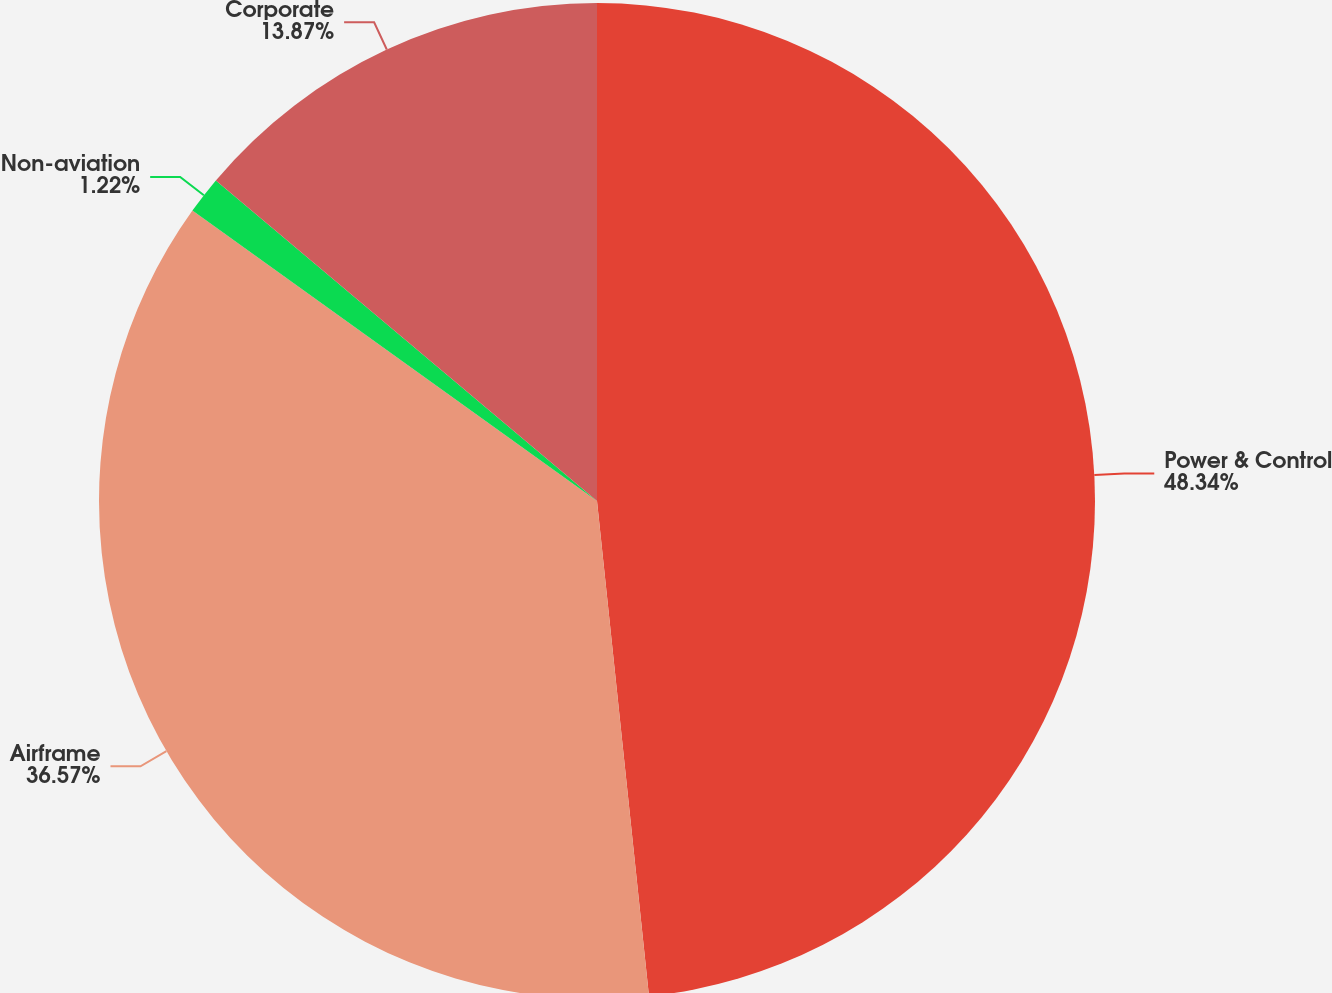<chart> <loc_0><loc_0><loc_500><loc_500><pie_chart><fcel>Power & Control<fcel>Airframe<fcel>Non-aviation<fcel>Corporate<nl><fcel>48.33%<fcel>36.57%<fcel>1.22%<fcel>13.87%<nl></chart> 